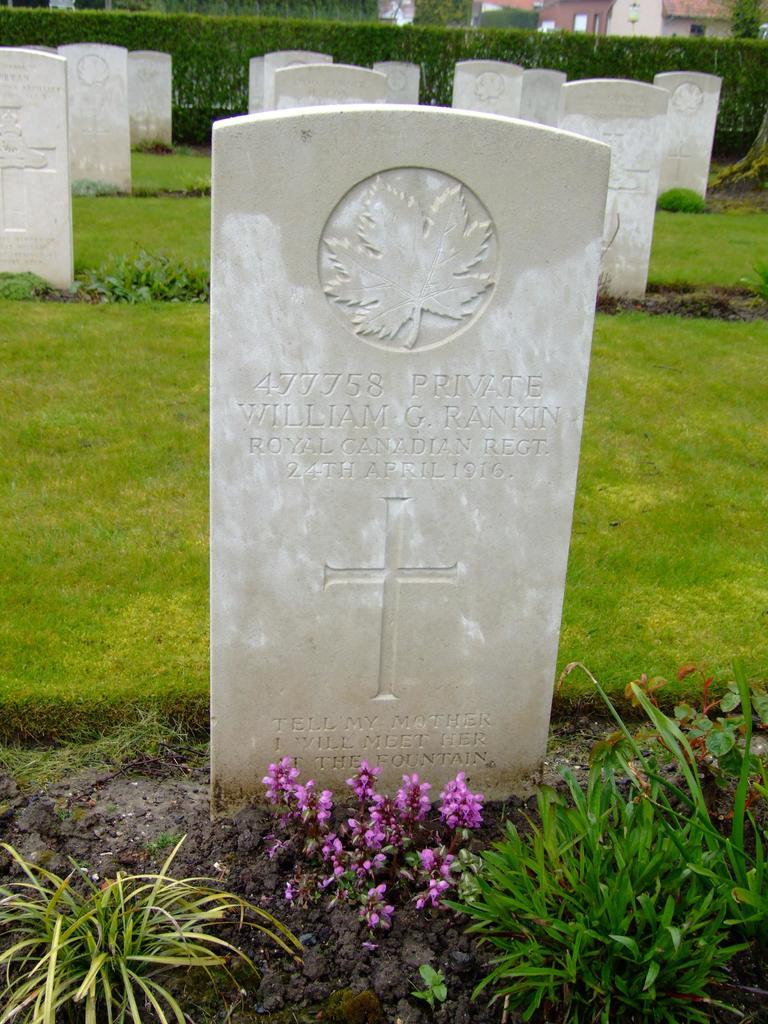What type of structures can be seen in the image? There are grave stones in the image. What other elements are present in the image besides the grave stones? There are plants and flowers in the image. What can be seen in the background of the image? There are buildings in the background of the image. What type of yarn is being used to decorate the grave stones in the image? There is no yarn present in the image; it features grave stones, plants, flowers, and buildings in the background. 